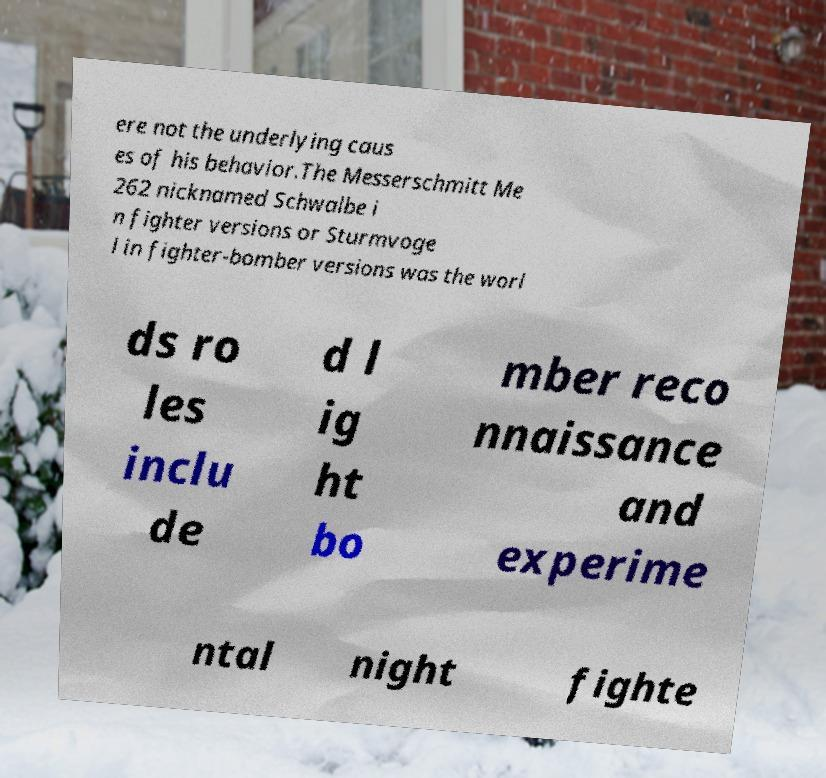Please read and relay the text visible in this image. What does it say? ere not the underlying caus es of his behavior.The Messerschmitt Me 262 nicknamed Schwalbe i n fighter versions or Sturmvoge l in fighter-bomber versions was the worl ds ro les inclu de d l ig ht bo mber reco nnaissance and experime ntal night fighte 